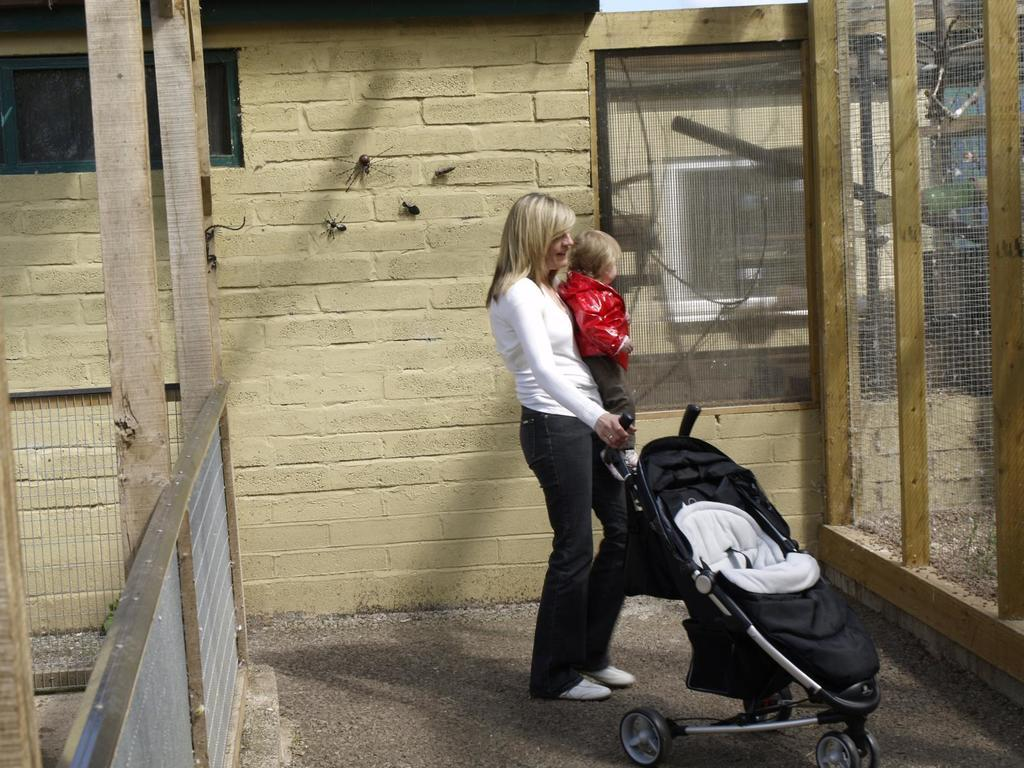Who is the main subject in the image? There is a lady in the image. What is the lady holding in the image? The lady is holding a baby and the handle of a stroller. What can be seen in the background of the image? There are net boundaries and spiders on the wall in the background of the image. How many grapes are hanging from the lady's toe in the image? There are no grapes present in the image, and the lady's toe is not mentioned in the provided facts. 